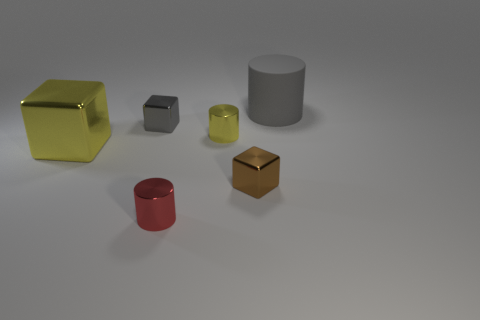Can you describe the shapes and colors of the objects in this image? Certainly! There are several objects in the image, all with distinct shapes and colors. Starting with the shapes, there's a large gray cylinder, a large yellow cube, a smaller gray cube, a smaller yellow cube, and a small red cylinder. Regarding colors, they are quite simple and vivid, with red, yellow, and gray represented in what appears to be a matte finish on all the objects. 